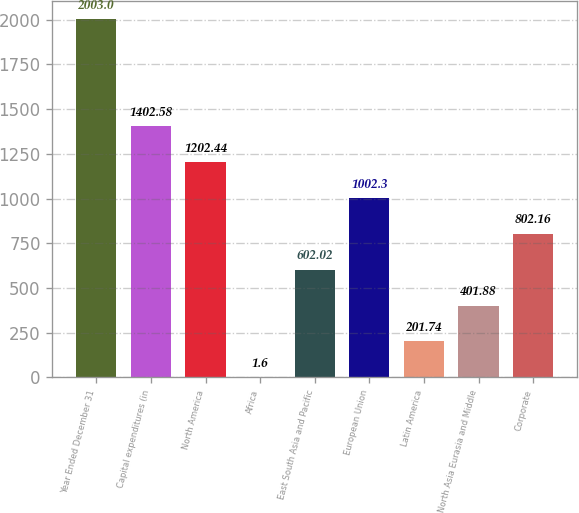<chart> <loc_0><loc_0><loc_500><loc_500><bar_chart><fcel>Year Ended December 31<fcel>Capital expenditures (in<fcel>North America<fcel>Africa<fcel>East South Asia and Pacific<fcel>European Union<fcel>Latin America<fcel>North Asia Eurasia and Middle<fcel>Corporate<nl><fcel>2003<fcel>1402.58<fcel>1202.44<fcel>1.6<fcel>602.02<fcel>1002.3<fcel>201.74<fcel>401.88<fcel>802.16<nl></chart> 